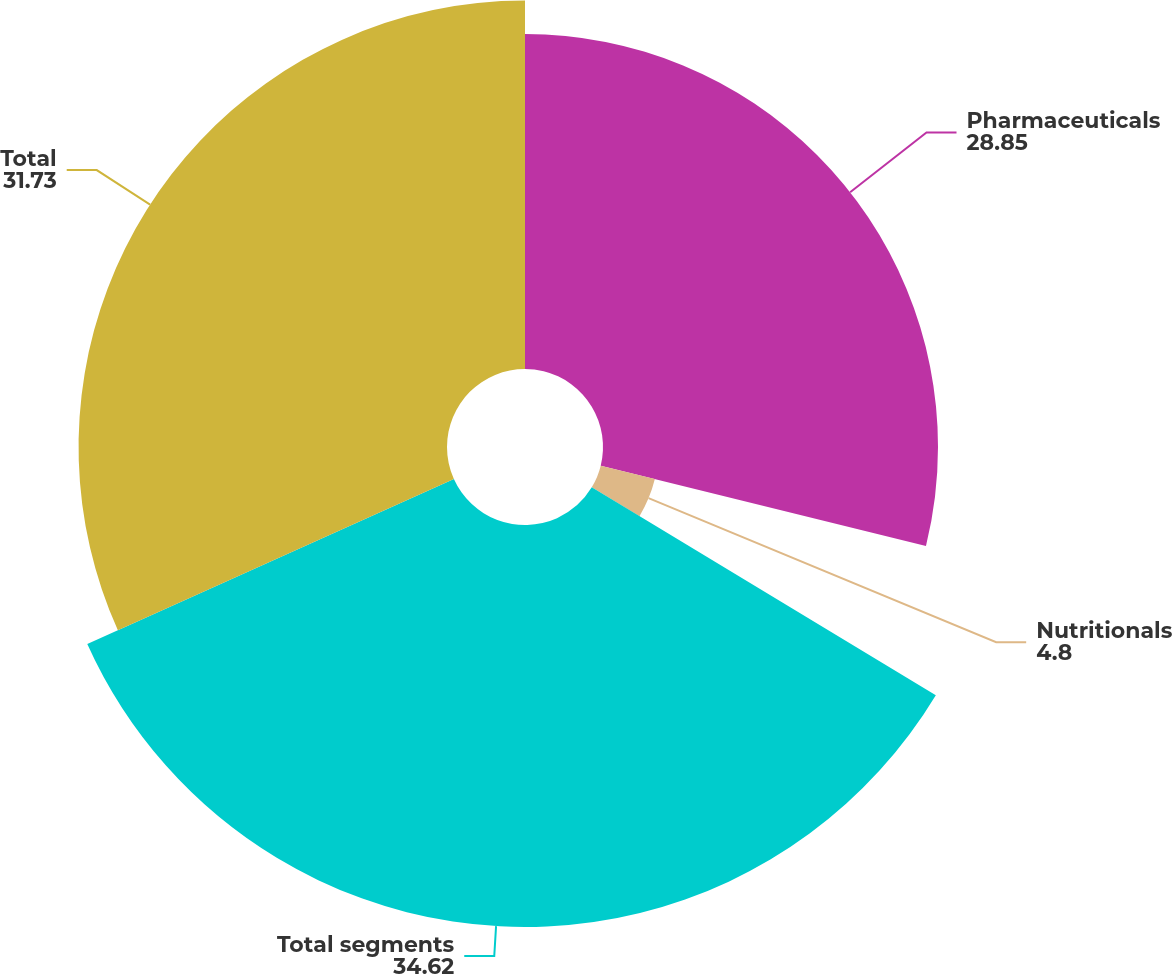<chart> <loc_0><loc_0><loc_500><loc_500><pie_chart><fcel>Pharmaceuticals<fcel>Nutritionals<fcel>Total segments<fcel>Total<nl><fcel>28.85%<fcel>4.8%<fcel>34.62%<fcel>31.73%<nl></chart> 